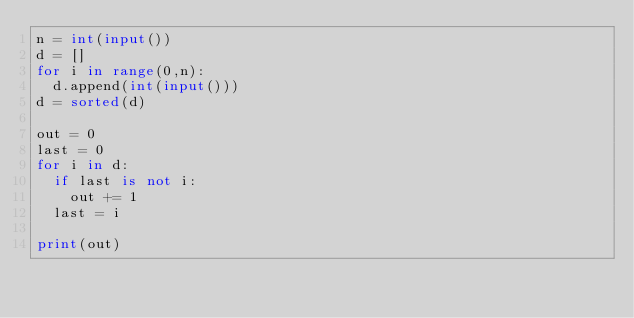Convert code to text. <code><loc_0><loc_0><loc_500><loc_500><_Python_>n = int(input())
d = []
for i in range(0,n):
  d.append(int(input()))
d = sorted(d)

out = 0
last = 0
for i in d:
  if last is not i:
    out += 1
  last = i

print(out)</code> 